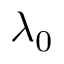Convert formula to latex. <formula><loc_0><loc_0><loc_500><loc_500>\lambda _ { 0 }</formula> 